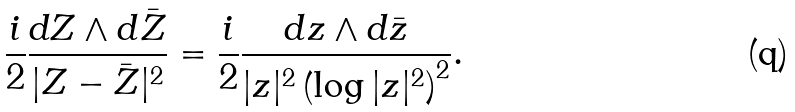Convert formula to latex. <formula><loc_0><loc_0><loc_500><loc_500>\frac { i } { 2 } \frac { d Z \wedge d \bar { Z } } { | Z - \bar { Z } | ^ { 2 } } = \frac { i } { 2 } \frac { d z \wedge d \bar { z } } { | z | ^ { 2 } \left ( \log | z | ^ { 2 } \right ) ^ { 2 } } .</formula> 